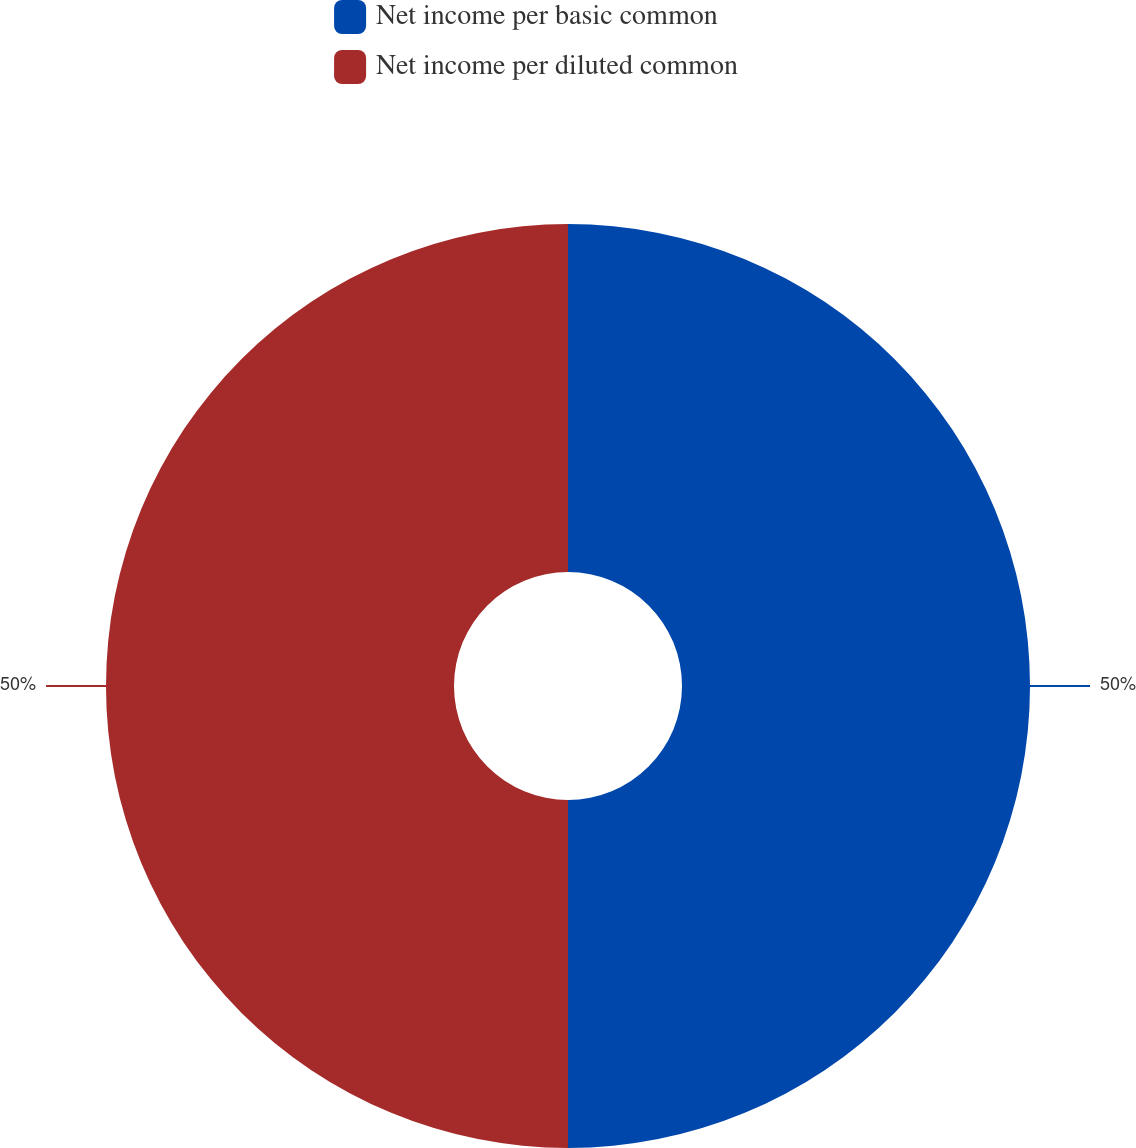Convert chart. <chart><loc_0><loc_0><loc_500><loc_500><pie_chart><fcel>Net income per basic common<fcel>Net income per diluted common<nl><fcel>50.0%<fcel>50.0%<nl></chart> 